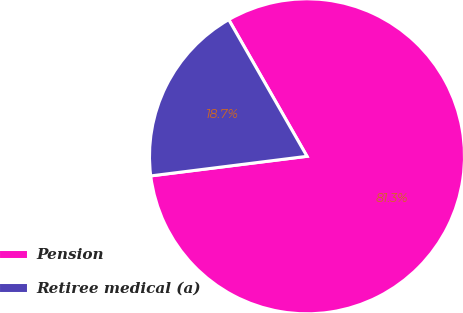<chart> <loc_0><loc_0><loc_500><loc_500><pie_chart><fcel>Pension<fcel>Retiree medical (a)<nl><fcel>81.29%<fcel>18.71%<nl></chart> 